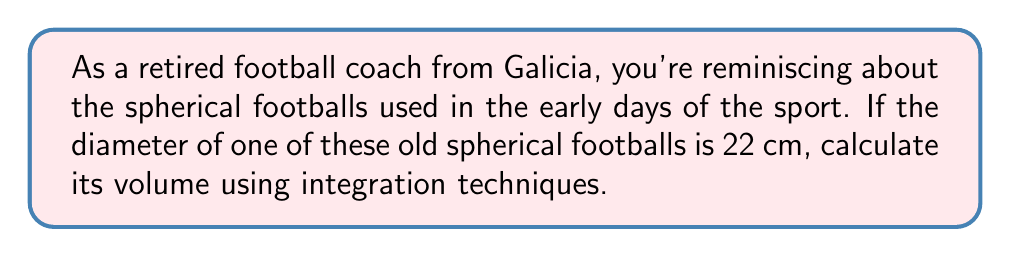Can you solve this math problem? Let's approach this step-by-step:

1) The volume of a sphere can be calculated using the formula:

   $$V = \int_{-r}^r \pi (r^2 - x^2) dx$$

   where $r$ is the radius of the sphere.

2) Given that the diameter is 22 cm, the radius is 11 cm.

3) Substituting $r = 11$ into our formula:

   $$V = \int_{-11}^{11} \pi (11^2 - x^2) dx$$

4) Simplify the integrand:

   $$V = \pi \int_{-11}^{11} (121 - x^2) dx$$

5) Integrate:

   $$V = \pi \left[121x - \frac{x^3}{3}\right]_{-11}^{11}$$

6) Evaluate the integral:

   $$V = \pi \left[(121(11) - \frac{11^3}{3}) - (121(-11) - \frac{(-11)^3}{3})\right]$$

7) Simplify:

   $$V = \pi \left[(1331 - \frac{1331}{3}) - (-1331 - \frac{-1331}{3})\right]$$
   $$V = \pi \left[1331 - 443.67 + 1331 + 443.67\right]$$
   $$V = 2662\pi$$

8) The volume is in cubic centimeters. Calculate the final result:

   $$V \approx 8361.28 \text{ cm}^3$$
Answer: $8361.28 \text{ cm}^3$ 